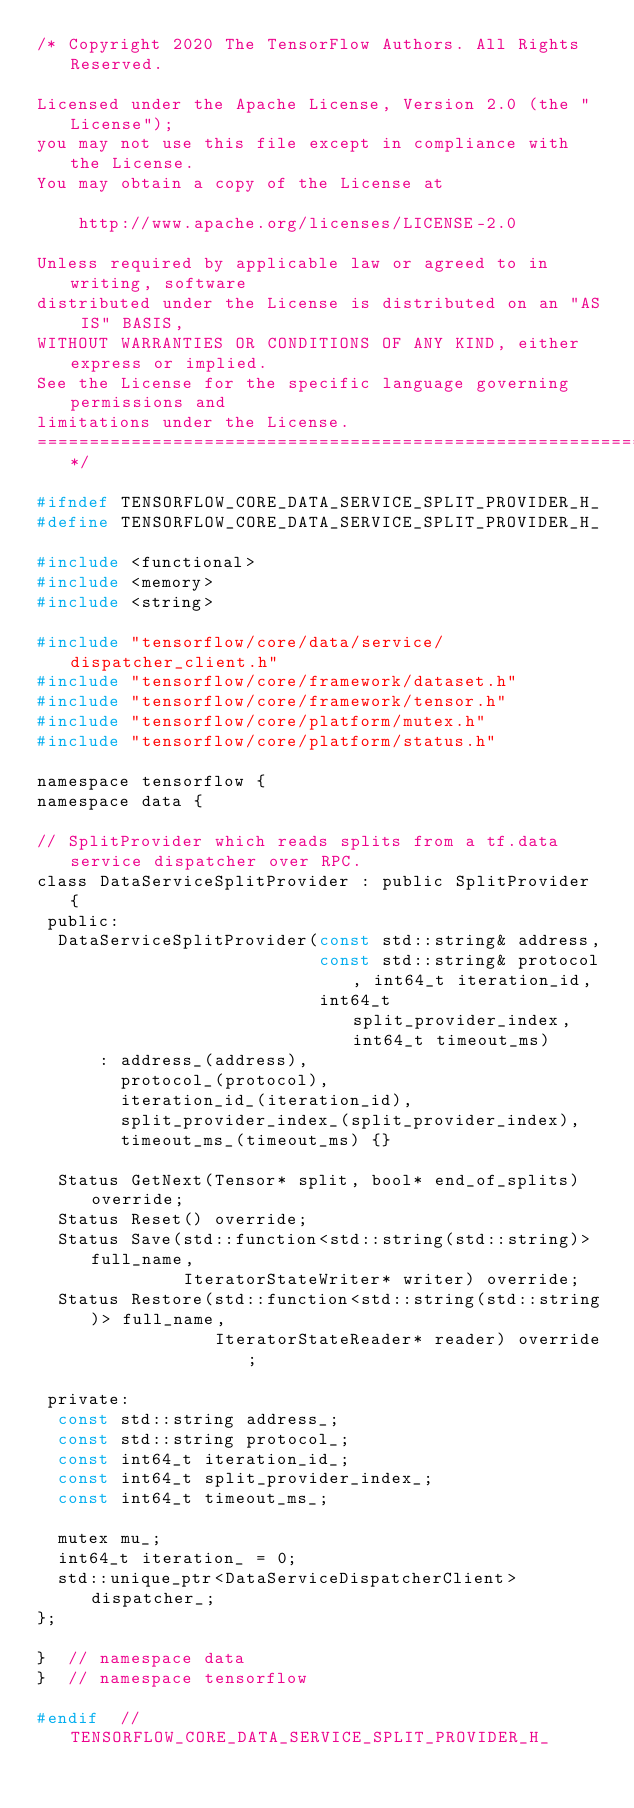Convert code to text. <code><loc_0><loc_0><loc_500><loc_500><_C_>/* Copyright 2020 The TensorFlow Authors. All Rights Reserved.

Licensed under the Apache License, Version 2.0 (the "License");
you may not use this file except in compliance with the License.
You may obtain a copy of the License at

    http://www.apache.org/licenses/LICENSE-2.0

Unless required by applicable law or agreed to in writing, software
distributed under the License is distributed on an "AS IS" BASIS,
WITHOUT WARRANTIES OR CONDITIONS OF ANY KIND, either express or implied.
See the License for the specific language governing permissions and
limitations under the License.
==============================================================================*/

#ifndef TENSORFLOW_CORE_DATA_SERVICE_SPLIT_PROVIDER_H_
#define TENSORFLOW_CORE_DATA_SERVICE_SPLIT_PROVIDER_H_

#include <functional>
#include <memory>
#include <string>

#include "tensorflow/core/data/service/dispatcher_client.h"
#include "tensorflow/core/framework/dataset.h"
#include "tensorflow/core/framework/tensor.h"
#include "tensorflow/core/platform/mutex.h"
#include "tensorflow/core/platform/status.h"

namespace tensorflow {
namespace data {

// SplitProvider which reads splits from a tf.data service dispatcher over RPC.
class DataServiceSplitProvider : public SplitProvider {
 public:
  DataServiceSplitProvider(const std::string& address,
                           const std::string& protocol, int64_t iteration_id,
                           int64_t split_provider_index, int64_t timeout_ms)
      : address_(address),
        protocol_(protocol),
        iteration_id_(iteration_id),
        split_provider_index_(split_provider_index),
        timeout_ms_(timeout_ms) {}

  Status GetNext(Tensor* split, bool* end_of_splits) override;
  Status Reset() override;
  Status Save(std::function<std::string(std::string)> full_name,
              IteratorStateWriter* writer) override;
  Status Restore(std::function<std::string(std::string)> full_name,
                 IteratorStateReader* reader) override;

 private:
  const std::string address_;
  const std::string protocol_;
  const int64_t iteration_id_;
  const int64_t split_provider_index_;
  const int64_t timeout_ms_;

  mutex mu_;
  int64_t iteration_ = 0;
  std::unique_ptr<DataServiceDispatcherClient> dispatcher_;
};

}  // namespace data
}  // namespace tensorflow

#endif  // TENSORFLOW_CORE_DATA_SERVICE_SPLIT_PROVIDER_H_
</code> 